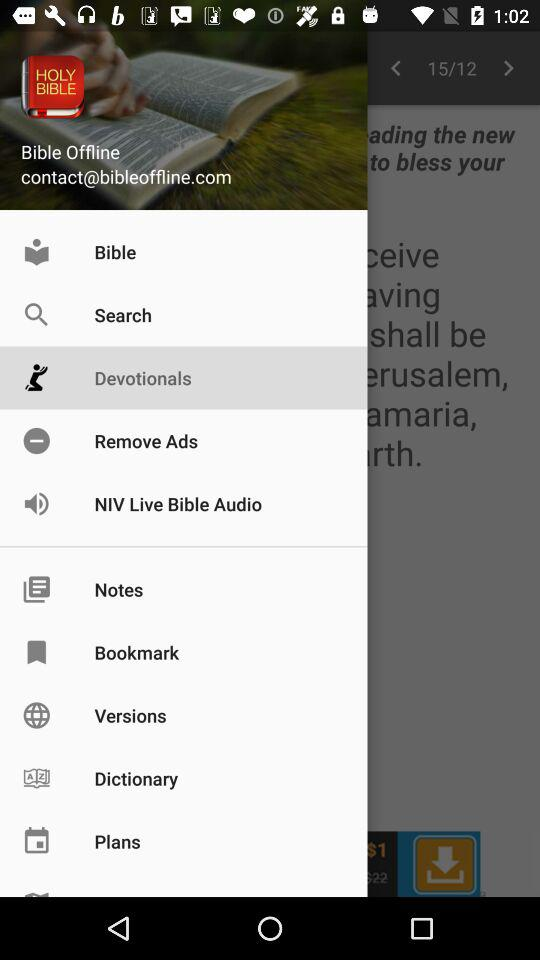What is the email address? The email address is contact@bibleoffline.com. 